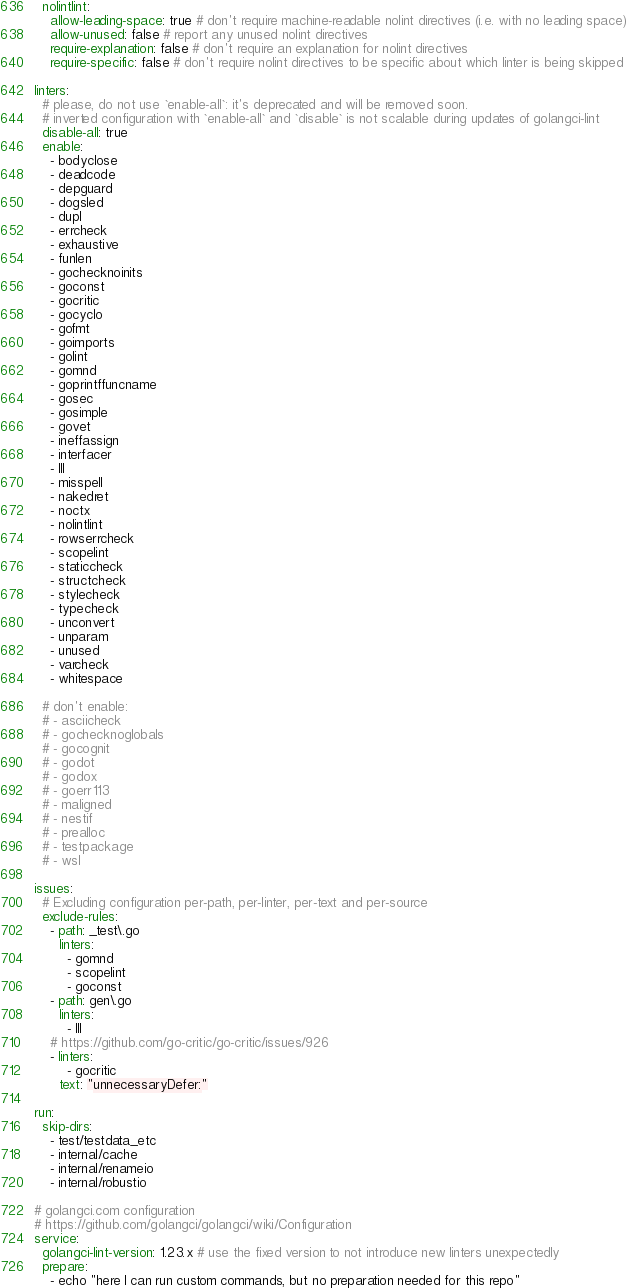Convert code to text. <code><loc_0><loc_0><loc_500><loc_500><_YAML_>  nolintlint:
    allow-leading-space: true # don't require machine-readable nolint directives (i.e. with no leading space)
    allow-unused: false # report any unused nolint directives
    require-explanation: false # don't require an explanation for nolint directives
    require-specific: false # don't require nolint directives to be specific about which linter is being skipped

linters:
  # please, do not use `enable-all`: it's deprecated and will be removed soon.
  # inverted configuration with `enable-all` and `disable` is not scalable during updates of golangci-lint
  disable-all: true
  enable:
    - bodyclose
    - deadcode
    - depguard
    - dogsled
    - dupl
    - errcheck
    - exhaustive
    - funlen
    - gochecknoinits
    - goconst
    - gocritic
    - gocyclo
    - gofmt
    - goimports
    - golint
    - gomnd
    - goprintffuncname
    - gosec
    - gosimple
    - govet
    - ineffassign
    - interfacer
    - lll
    - misspell
    - nakedret
    - noctx
    - nolintlint
    - rowserrcheck
    - scopelint
    - staticcheck
    - structcheck
    - stylecheck
    - typecheck
    - unconvert
    - unparam
    - unused
    - varcheck
    - whitespace

  # don't enable:
  # - asciicheck
  # - gochecknoglobals
  # - gocognit
  # - godot
  # - godox
  # - goerr113
  # - maligned
  # - nestif
  # - prealloc
  # - testpackage
  # - wsl

issues:
  # Excluding configuration per-path, per-linter, per-text and per-source
  exclude-rules:
    - path: _test\.go
      linters:
        - gomnd
        - scopelint
        - goconst
    - path: gen\.go
      linters:
        - lll
    # https://github.com/go-critic/go-critic/issues/926
    - linters:
        - gocritic
      text: "unnecessaryDefer:"

run:
  skip-dirs:
    - test/testdata_etc
    - internal/cache
    - internal/renameio
    - internal/robustio

# golangci.com configuration
# https://github.com/golangci/golangci/wiki/Configuration
service:
  golangci-lint-version: 1.23.x # use the fixed version to not introduce new linters unexpectedly
  prepare:
    - echo "here I can run custom commands, but no preparation needed for this repo"</code> 